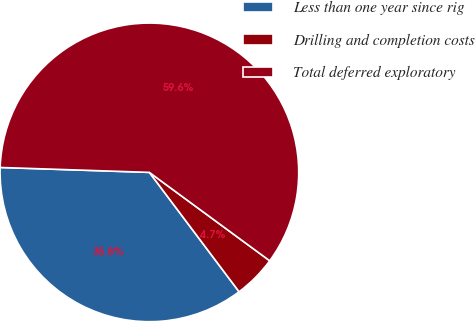Convert chart. <chart><loc_0><loc_0><loc_500><loc_500><pie_chart><fcel>Less than one year since rig<fcel>Drilling and completion costs<fcel>Total deferred exploratory<nl><fcel>35.78%<fcel>4.66%<fcel>59.56%<nl></chart> 